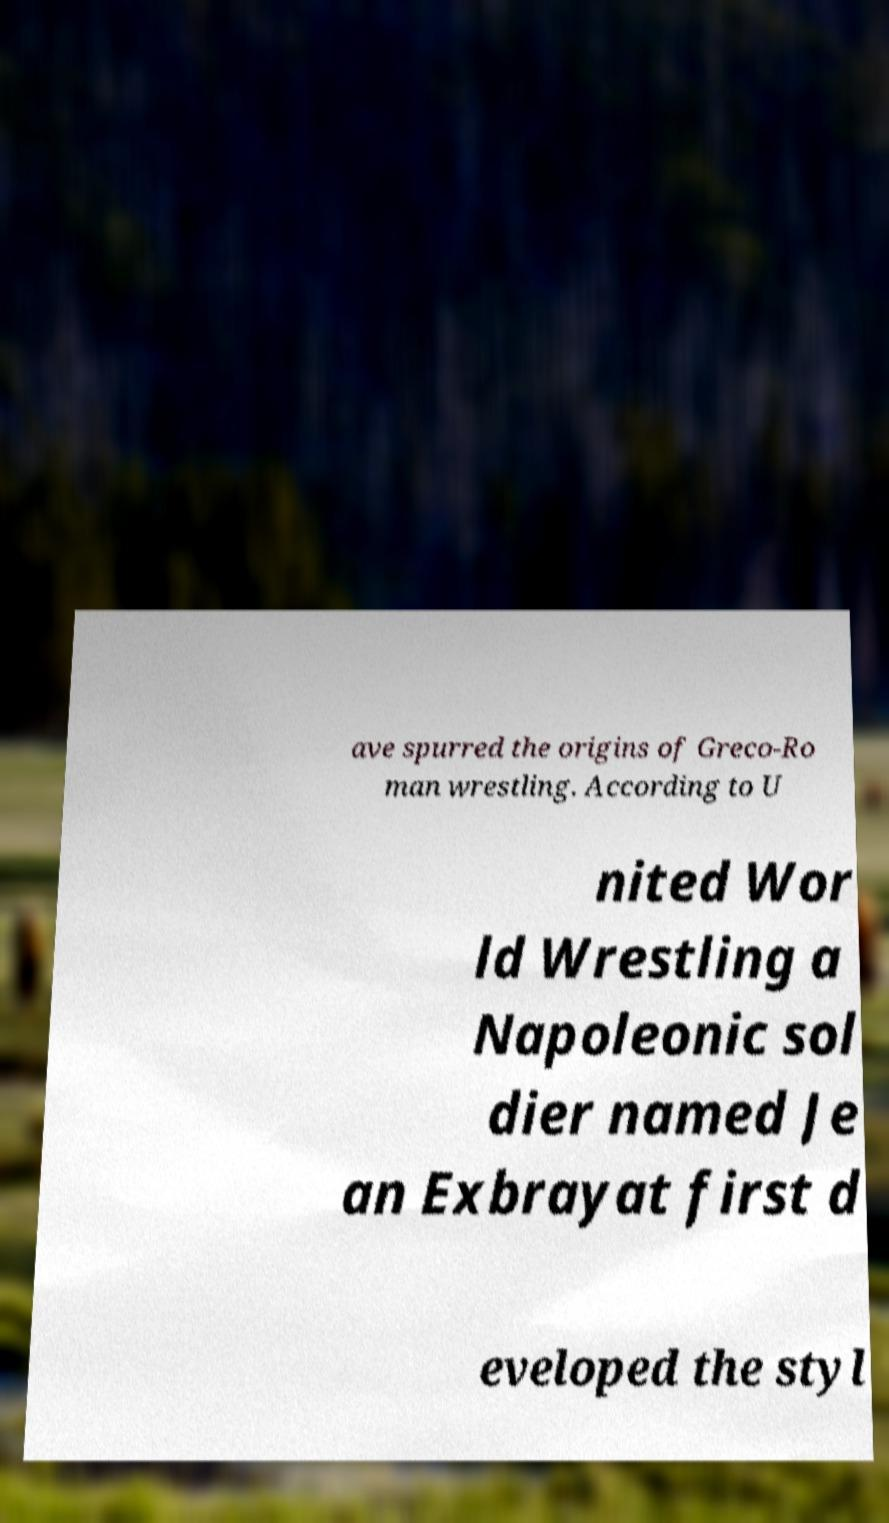For documentation purposes, I need the text within this image transcribed. Could you provide that? ave spurred the origins of Greco-Ro man wrestling. According to U nited Wor ld Wrestling a Napoleonic sol dier named Je an Exbrayat first d eveloped the styl 